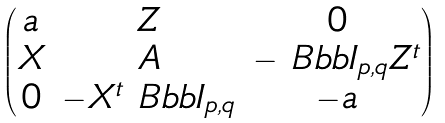Convert formula to latex. <formula><loc_0><loc_0><loc_500><loc_500>\begin{pmatrix} a & Z & 0 \\ X & A & - \ B b b I _ { p , q } Z ^ { t } \\ 0 & - X ^ { t } \ B b b I _ { p , q } & - a \end{pmatrix}</formula> 